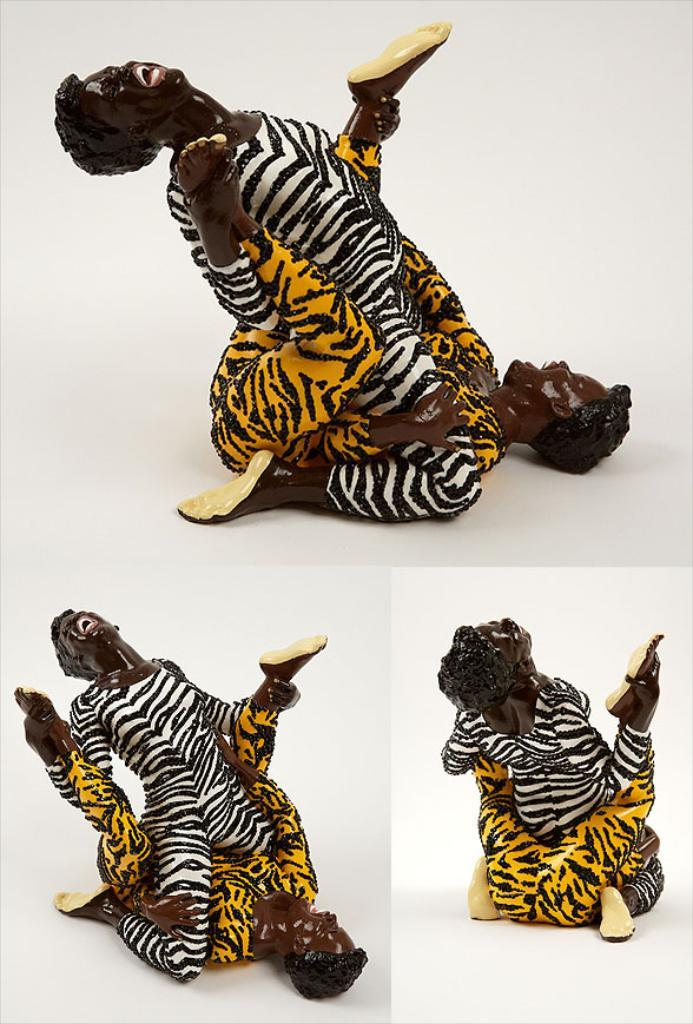What is the main subject of the image? The main subject of the image is a statue of two persons. How are the two persons positioned in the statue? The two persons are sitting on each other in the statue. What is located below the statue in the image? There is a photo grid below the statue. What type of harmony can be heard between the two persons in the statue? There is no sound or harmony present in the image, as it is a statue of two persons. How many beads are visible on the statue? There are no beads present on the statue; it is a statue of two persons sitting on each other. 